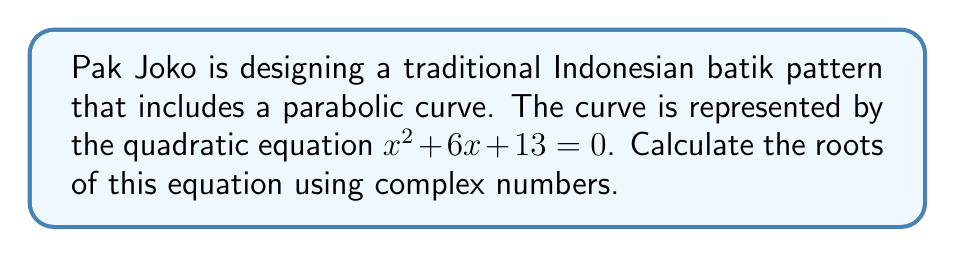Teach me how to tackle this problem. To find the roots of the quadratic equation $x^2 + 6x + 13 = 0$, we'll use the quadratic formula:

$$x = \frac{-b \pm \sqrt{b^2 - 4ac}}{2a}$$

Where $a = 1$, $b = 6$, and $c = 13$.

Step 1: Calculate the discriminant $b^2 - 4ac$
$$b^2 - 4ac = 6^2 - 4(1)(13) = 36 - 52 = -16$$

Step 2: Substitute into the quadratic formula
$$x = \frac{-6 \pm \sqrt{-16}}{2(1)}$$

Step 3: Simplify the square root of a negative number
$\sqrt{-16} = \sqrt{16} \cdot \sqrt{-1} = 4i$

$$x = \frac{-6 \pm 4i}{2}$$

Step 4: Simplify the fraction
$$x = -3 \pm 2i$$

Therefore, the two roots are:
$x_1 = -3 + 2i$ and $x_2 = -3 - 2i$
Answer: $x_1 = -3 + 2i$, $x_2 = -3 - 2i$ 